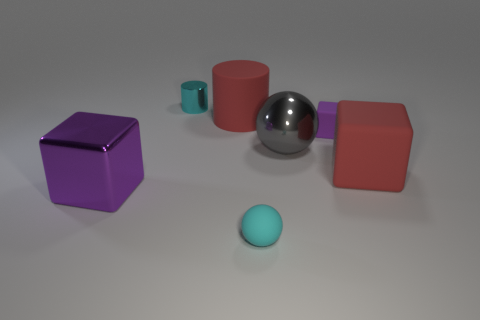How many balls have the same size as the cyan metallic cylinder?
Make the answer very short. 1. Is the material of the big cube that is right of the tiny cyan metal cylinder the same as the gray ball?
Ensure brevity in your answer.  No. Is there a small brown rubber object?
Offer a terse response. No. There is a red cylinder that is made of the same material as the tiny cyan ball; what size is it?
Provide a succinct answer. Large. Are there any other tiny balls of the same color as the matte sphere?
Your answer should be compact. No. There is a sphere behind the tiny cyan matte ball; is its color the same as the ball left of the gray metal thing?
Offer a very short reply. No. What is the size of the cylinder that is the same color as the rubber sphere?
Make the answer very short. Small. Are there any tiny cylinders that have the same material as the large purple thing?
Your answer should be compact. Yes. The small metallic thing has what color?
Your response must be concise. Cyan. What size is the ball behind the purple cube in front of the red matte cube to the right of the big purple block?
Your response must be concise. Large. 